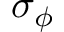<formula> <loc_0><loc_0><loc_500><loc_500>\sigma _ { \phi }</formula> 